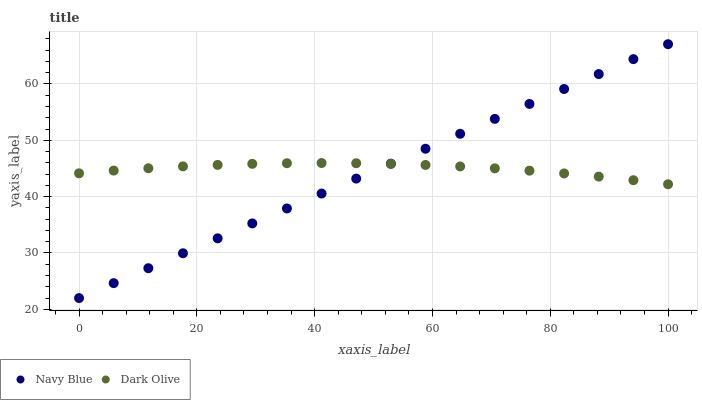Does Navy Blue have the minimum area under the curve?
Answer yes or no. Yes. Does Dark Olive have the maximum area under the curve?
Answer yes or no. Yes. Does Dark Olive have the minimum area under the curve?
Answer yes or no. No. Is Navy Blue the smoothest?
Answer yes or no. Yes. Is Dark Olive the roughest?
Answer yes or no. Yes. Is Dark Olive the smoothest?
Answer yes or no. No. Does Navy Blue have the lowest value?
Answer yes or no. Yes. Does Dark Olive have the lowest value?
Answer yes or no. No. Does Navy Blue have the highest value?
Answer yes or no. Yes. Does Dark Olive have the highest value?
Answer yes or no. No. Does Navy Blue intersect Dark Olive?
Answer yes or no. Yes. Is Navy Blue less than Dark Olive?
Answer yes or no. No. Is Navy Blue greater than Dark Olive?
Answer yes or no. No. 